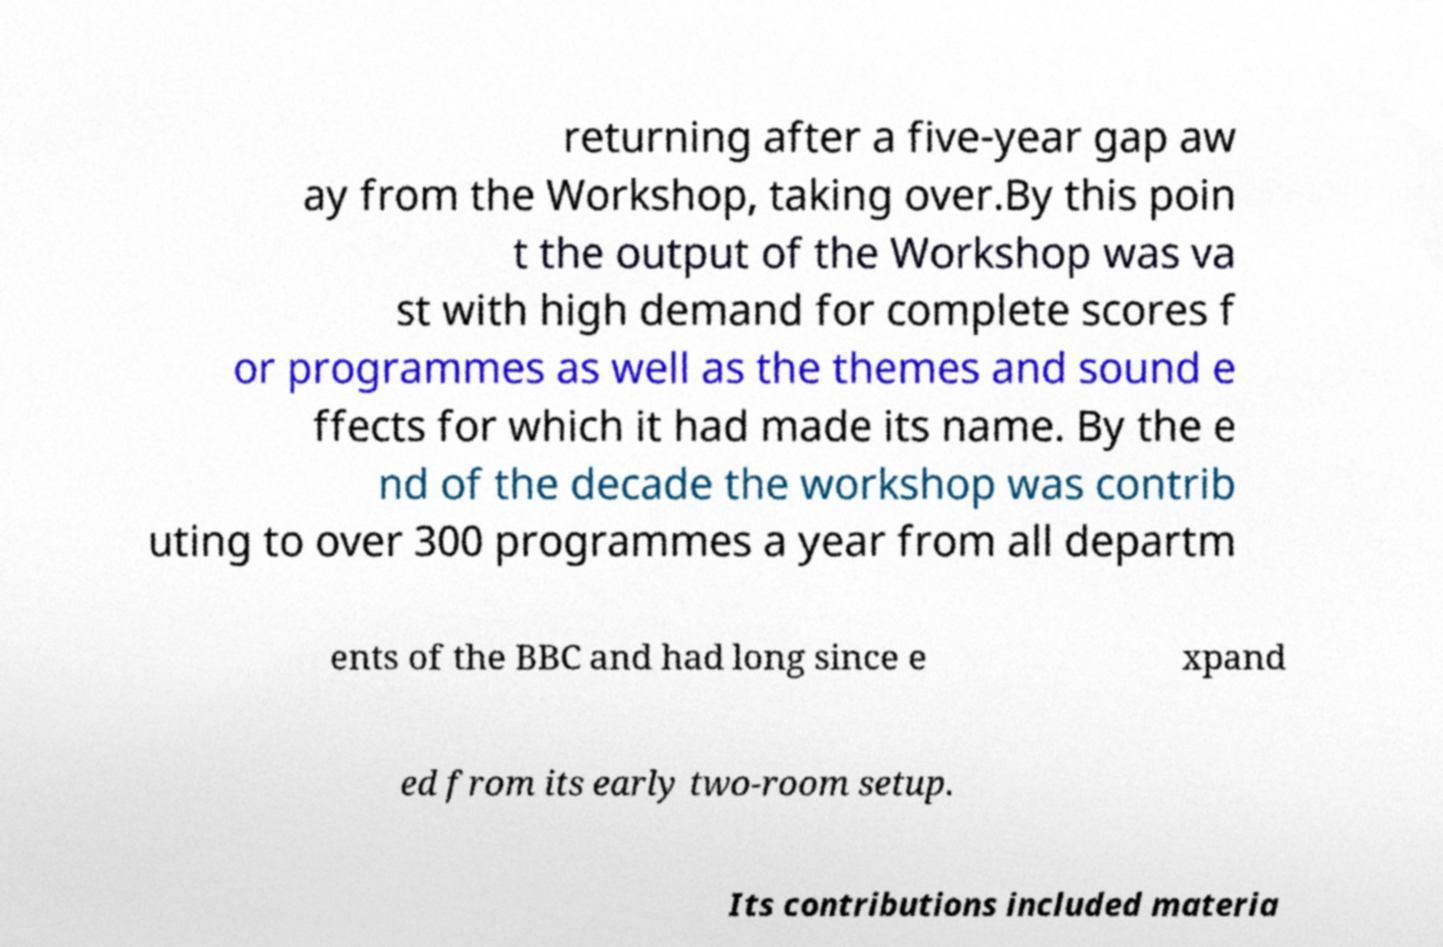For documentation purposes, I need the text within this image transcribed. Could you provide that? returning after a five-year gap aw ay from the Workshop, taking over.By this poin t the output of the Workshop was va st with high demand for complete scores f or programmes as well as the themes and sound e ffects for which it had made its name. By the e nd of the decade the workshop was contrib uting to over 300 programmes a year from all departm ents of the BBC and had long since e xpand ed from its early two-room setup. Its contributions included materia 